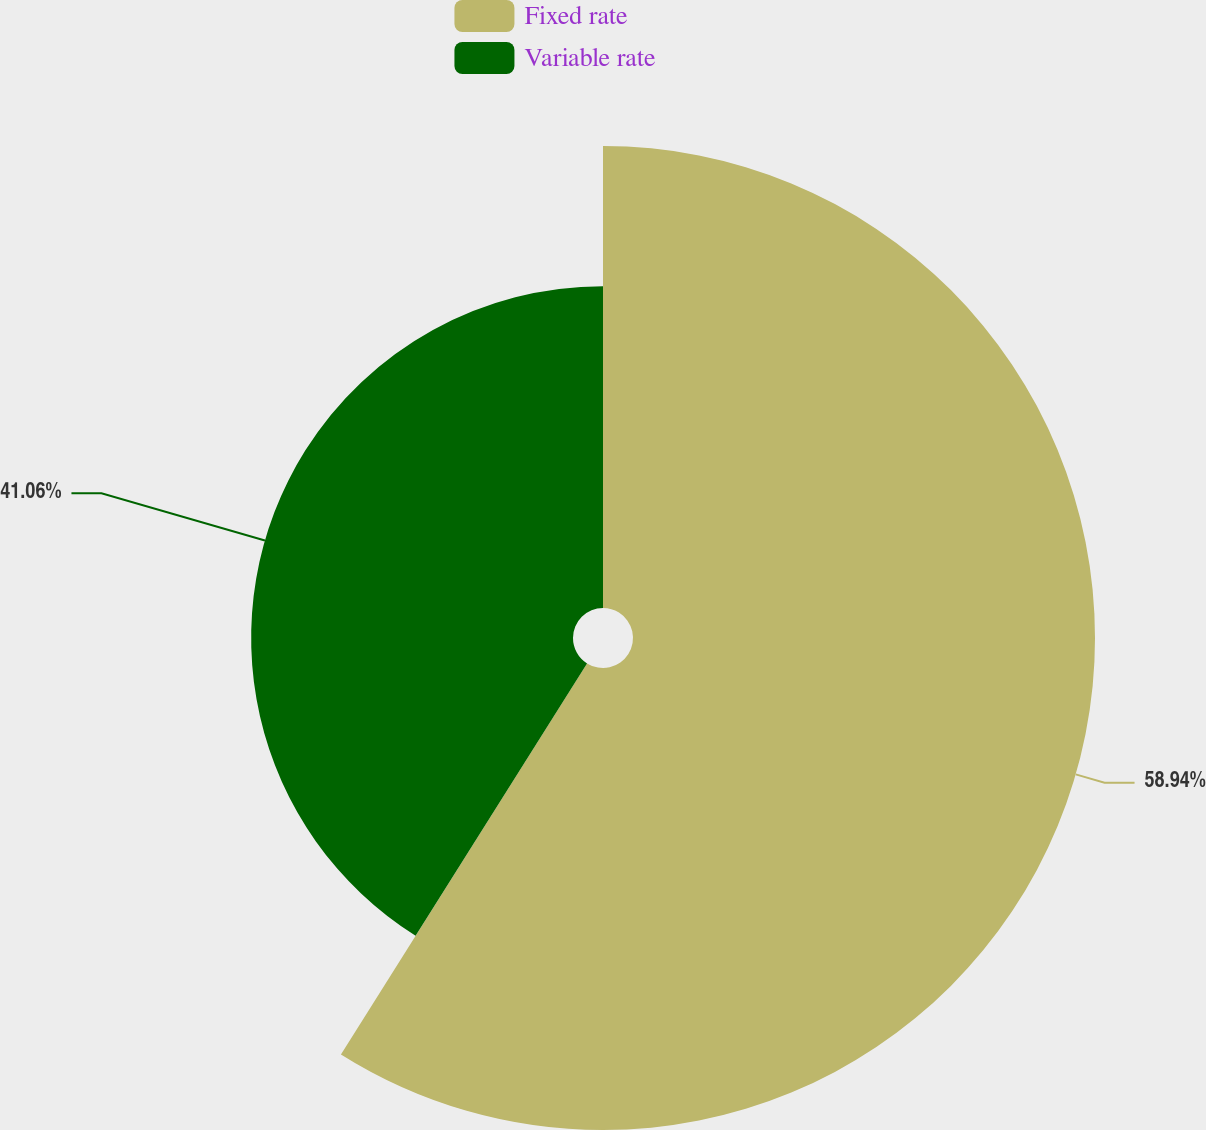<chart> <loc_0><loc_0><loc_500><loc_500><pie_chart><fcel>Fixed rate<fcel>Variable rate<nl><fcel>58.94%<fcel>41.06%<nl></chart> 